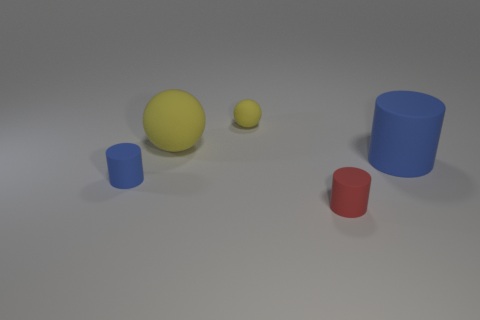Add 2 tiny cylinders. How many objects exist? 7 Subtract all spheres. How many objects are left? 3 Add 3 cylinders. How many cylinders exist? 6 Subtract 0 blue cubes. How many objects are left? 5 Subtract all gray metallic blocks. Subtract all small red things. How many objects are left? 4 Add 3 yellow balls. How many yellow balls are left? 5 